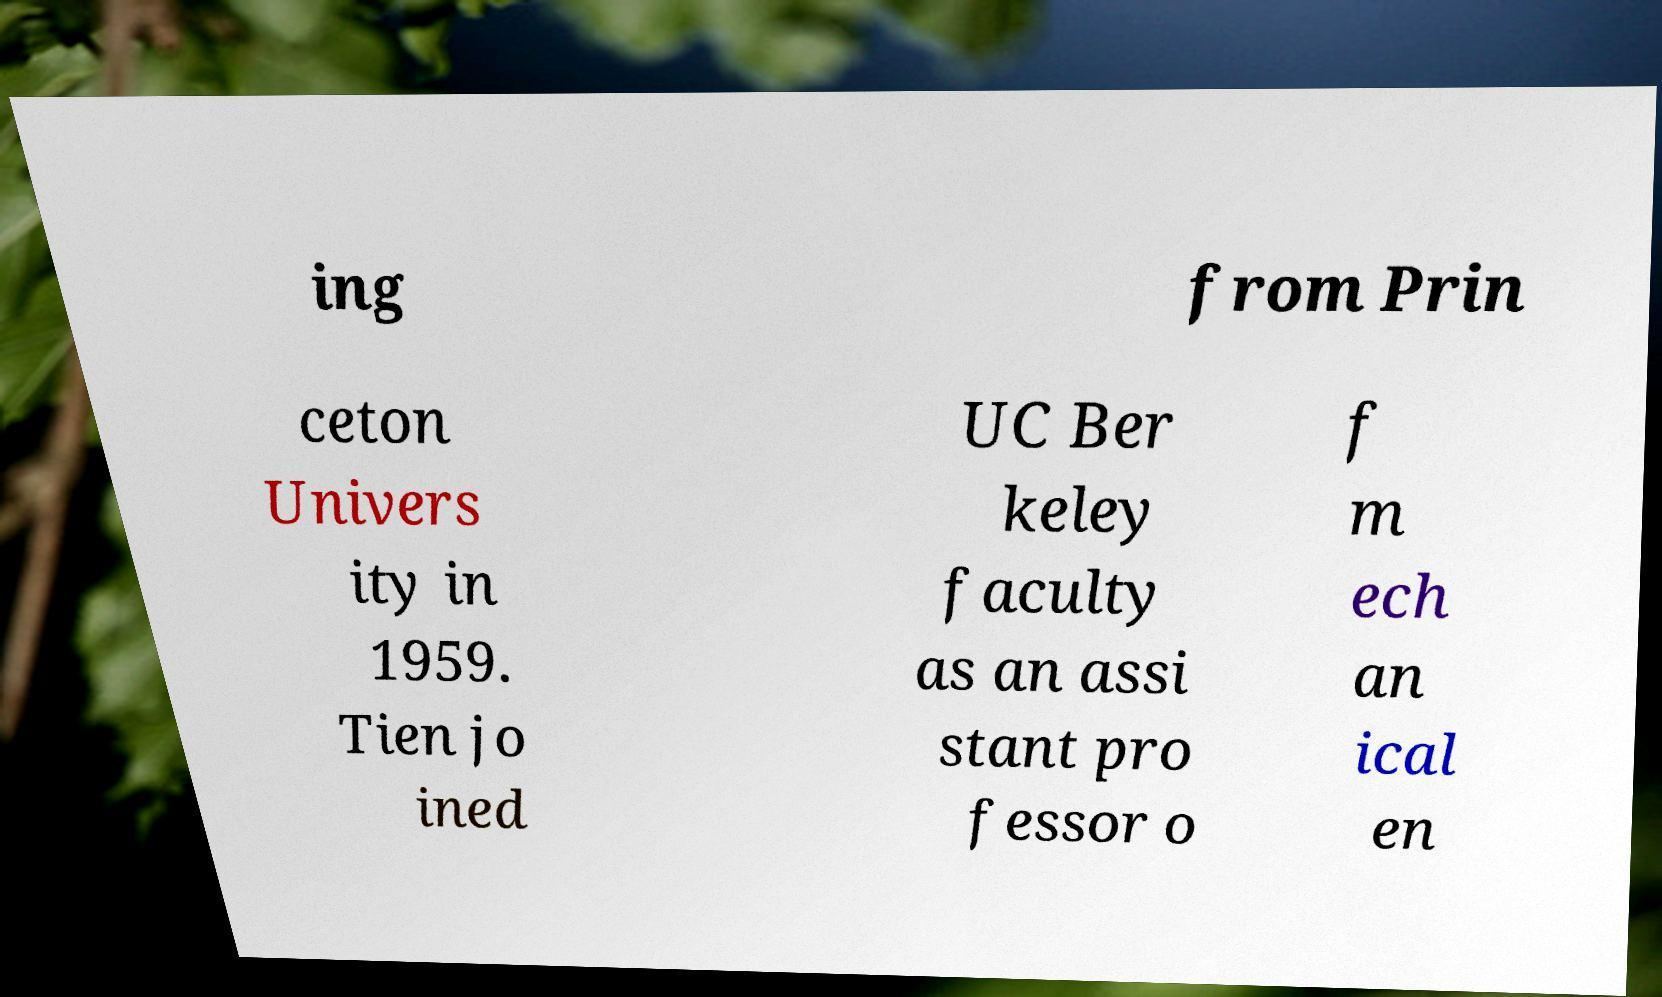There's text embedded in this image that I need extracted. Can you transcribe it verbatim? ing from Prin ceton Univers ity in 1959. Tien jo ined UC Ber keley faculty as an assi stant pro fessor o f m ech an ical en 